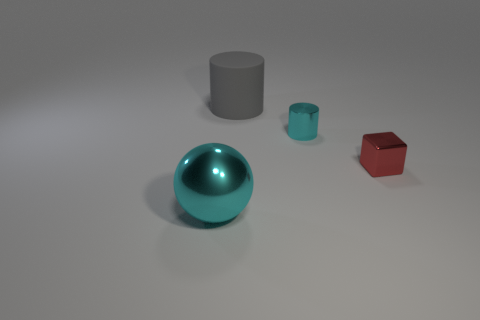What size is the shiny thing that is both left of the red object and in front of the small cyan metal cylinder?
Provide a succinct answer. Large. What number of metal objects are balls or tiny blue balls?
Your answer should be very brief. 1. What material is the large gray object?
Give a very brief answer. Rubber. There is a cyan object that is behind the cyan shiny object that is left of the large thing right of the large cyan metal object; what is it made of?
Keep it short and to the point. Metal. There is a shiny object that is the same size as the gray matte object; what shape is it?
Offer a terse response. Sphere. What number of things are tiny blue metal spheres or tiny shiny blocks that are in front of the large cylinder?
Make the answer very short. 1. Is the material of the cylinder that is right of the gray rubber object the same as the large thing behind the small metallic cylinder?
Offer a terse response. No. There is a shiny thing that is the same color as the large metal ball; what is its shape?
Ensure brevity in your answer.  Cylinder. How many gray objects are cylinders or big things?
Provide a succinct answer. 1. The cube has what size?
Make the answer very short. Small. 